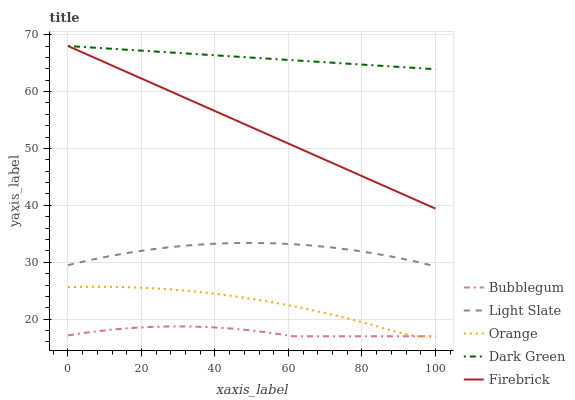Does Bubblegum have the minimum area under the curve?
Answer yes or no. Yes. Does Dark Green have the maximum area under the curve?
Answer yes or no. Yes. Does Orange have the minimum area under the curve?
Answer yes or no. No. Does Orange have the maximum area under the curve?
Answer yes or no. No. Is Firebrick the smoothest?
Answer yes or no. Yes. Is Orange the roughest?
Answer yes or no. Yes. Is Orange the smoothest?
Answer yes or no. No. Is Firebrick the roughest?
Answer yes or no. No. Does Orange have the lowest value?
Answer yes or no. Yes. Does Firebrick have the lowest value?
Answer yes or no. No. Does Dark Green have the highest value?
Answer yes or no. Yes. Does Orange have the highest value?
Answer yes or no. No. Is Bubblegum less than Dark Green?
Answer yes or no. Yes. Is Light Slate greater than Bubblegum?
Answer yes or no. Yes. Does Orange intersect Bubblegum?
Answer yes or no. Yes. Is Orange less than Bubblegum?
Answer yes or no. No. Is Orange greater than Bubblegum?
Answer yes or no. No. Does Bubblegum intersect Dark Green?
Answer yes or no. No. 